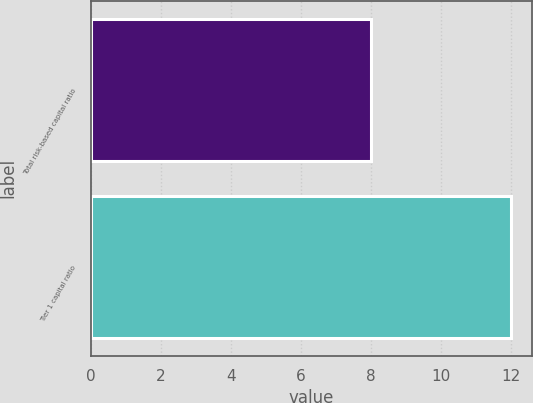Convert chart to OTSL. <chart><loc_0><loc_0><loc_500><loc_500><bar_chart><fcel>Total risk-based capital ratio<fcel>Tier 1 capital ratio<nl><fcel>8<fcel>12<nl></chart> 